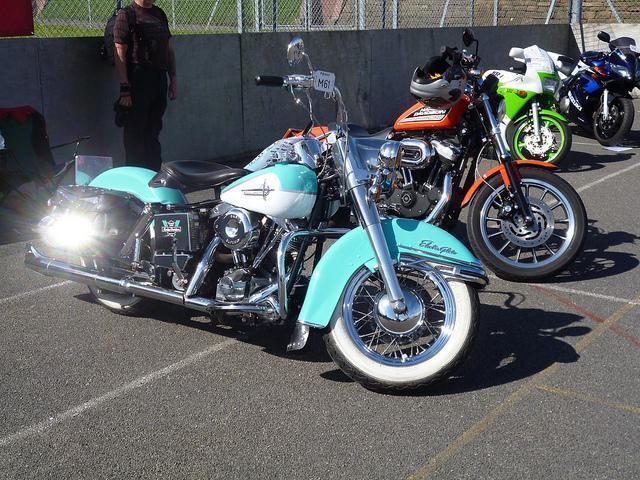How many motorcycles are visible?
Give a very brief answer. 4. How many people reaching for the frisbee are wearing red?
Give a very brief answer. 0. 